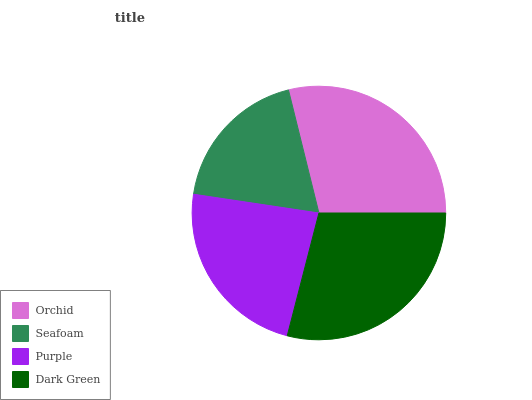Is Seafoam the minimum?
Answer yes or no. Yes. Is Dark Green the maximum?
Answer yes or no. Yes. Is Purple the minimum?
Answer yes or no. No. Is Purple the maximum?
Answer yes or no. No. Is Purple greater than Seafoam?
Answer yes or no. Yes. Is Seafoam less than Purple?
Answer yes or no. Yes. Is Seafoam greater than Purple?
Answer yes or no. No. Is Purple less than Seafoam?
Answer yes or no. No. Is Orchid the high median?
Answer yes or no. Yes. Is Purple the low median?
Answer yes or no. Yes. Is Dark Green the high median?
Answer yes or no. No. Is Dark Green the low median?
Answer yes or no. No. 